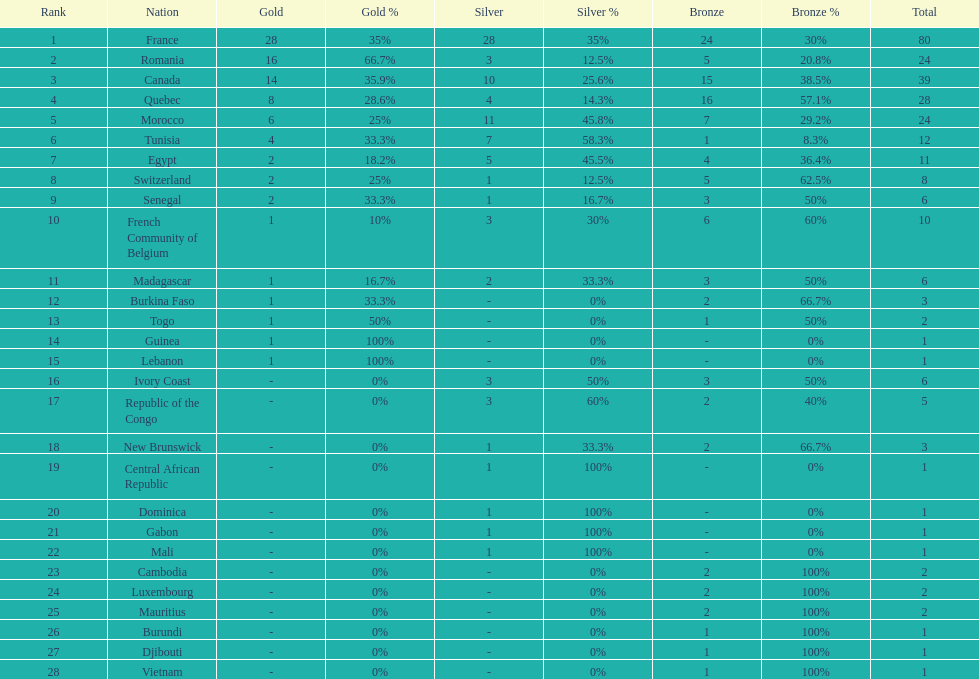How many bronze medals does togo have? 1. 